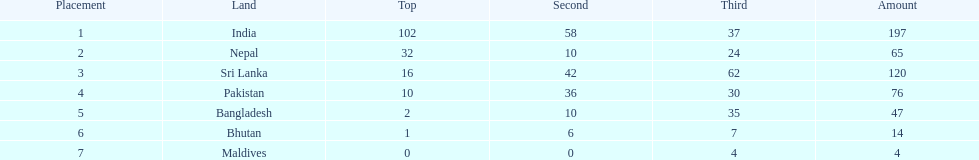Could you parse the entire table as a dict? {'header': ['Placement', 'Land', 'Top', 'Second', 'Third', 'Amount'], 'rows': [['1', 'India', '102', '58', '37', '197'], ['2', 'Nepal', '32', '10', '24', '65'], ['3', 'Sri Lanka', '16', '42', '62', '120'], ['4', 'Pakistan', '10', '36', '30', '76'], ['5', 'Bangladesh', '2', '10', '35', '47'], ['6', 'Bhutan', '1', '6', '7', '14'], ['7', 'Maldives', '0', '0', '4', '4']]} What was the only nation to win less than 10 medals total? Maldives. 